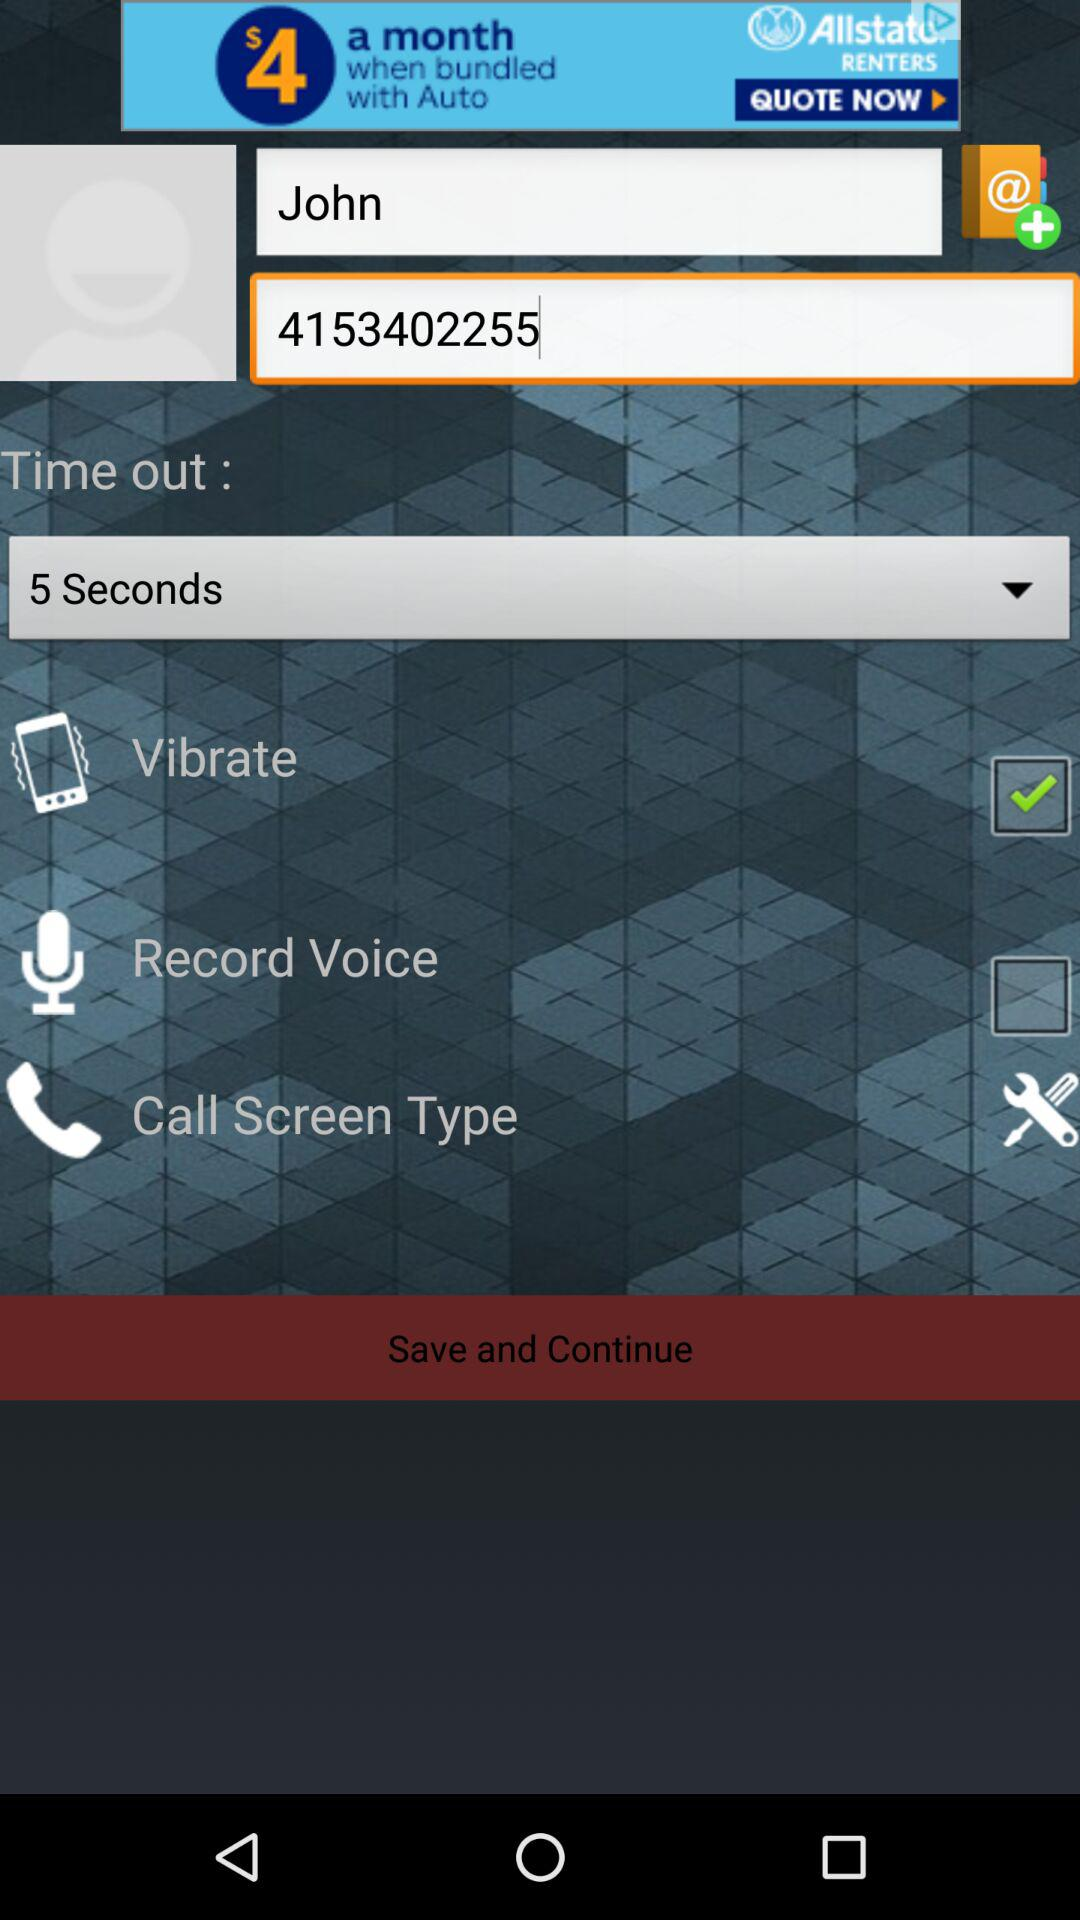What is the status of "Vibrate"? The status of "Vibrate" is "on". 